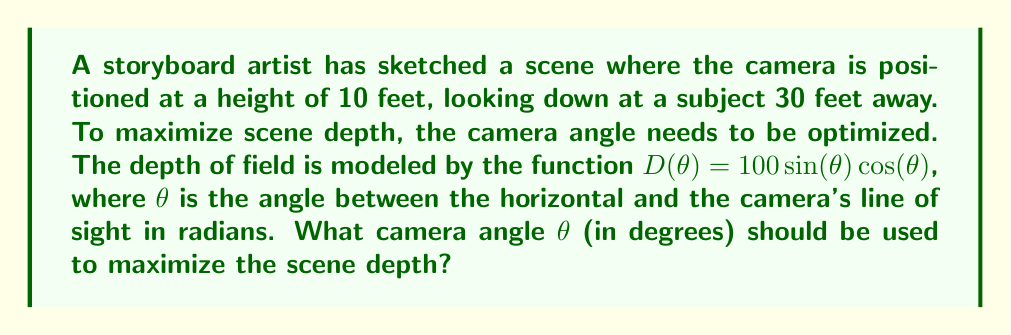Give your solution to this math problem. To solve this problem, we'll follow these steps:

1) The depth function is given by $D(\theta) = 100\sin(\theta)\cos(\theta)$

2) To find the maximum value of $D(\theta)$, we need to find where its derivative equals zero:

   $\frac{d}{d\theta}D(\theta) = 100(\cos^2(\theta) - \sin^2(\theta)) = 0$

3) Using the identity $\cos^2(\theta) - \sin^2(\theta) = \cos(2\theta)$, we get:

   $100\cos(2\theta) = 0$

4) Solving this equation:
   $\cos(2\theta) = 0$
   $2\theta = \frac{\pi}{2}$ or $\frac{3\pi}{2}$
   $\theta = \frac{\pi}{4}$ or $\frac{3\pi}{4}$

5) The $\frac{\pi}{4}$ solution gives us the maximum (the $\frac{3\pi}{4}$ solution gives a minimum).

6) Convert radians to degrees:
   $\frac{\pi}{4}$ radians = $45$ degrees

7) Verify this matches the given scenario:
   $\tan(\frac{\pi}{4}) = 1 = \frac{10}{30} = \frac{\text{height}}{\text{distance}}$

Therefore, the optimal camera angle is 45 degrees.
Answer: 45° 